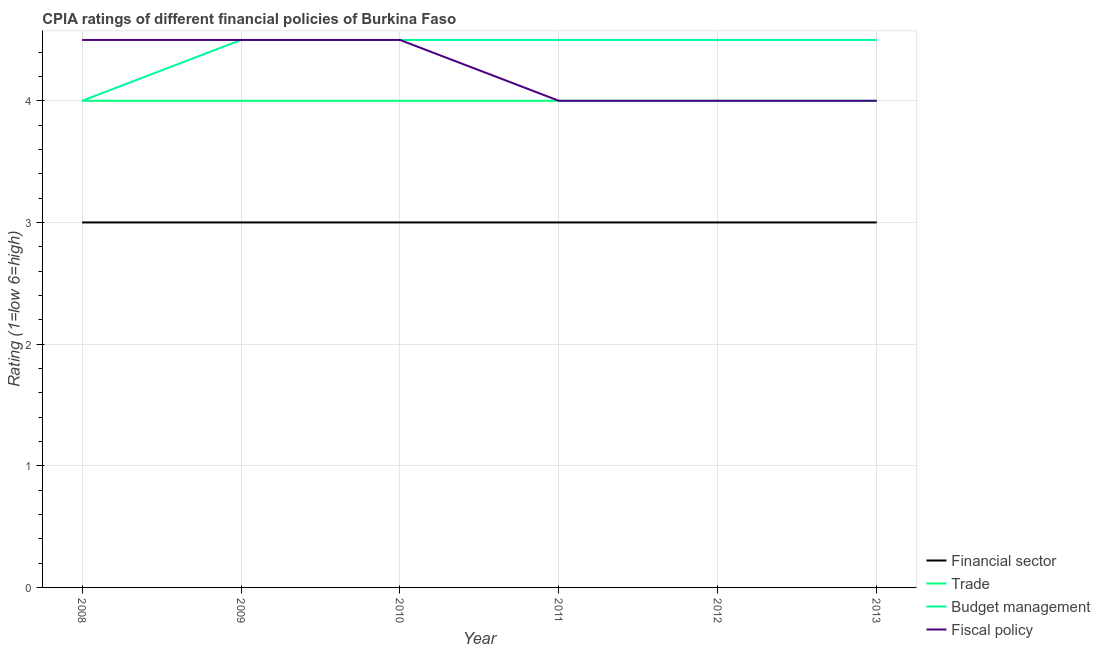How many different coloured lines are there?
Provide a short and direct response. 4. Is the number of lines equal to the number of legend labels?
Your answer should be compact. Yes. What is the cpia rating of budget management in 2009?
Your answer should be very brief. 4.5. Across all years, what is the maximum cpia rating of financial sector?
Your response must be concise. 3. What is the total cpia rating of trade in the graph?
Your answer should be compact. 24. What is the difference between the cpia rating of trade in 2009 and that in 2011?
Offer a very short reply. 0. What is the difference between the cpia rating of budget management in 2012 and the cpia rating of trade in 2009?
Ensure brevity in your answer.  0.5. What is the average cpia rating of budget management per year?
Offer a very short reply. 4.42. In the year 2008, what is the difference between the cpia rating of budget management and cpia rating of financial sector?
Make the answer very short. 1. What is the difference between the highest and the second highest cpia rating of budget management?
Offer a terse response. 0. In how many years, is the cpia rating of financial sector greater than the average cpia rating of financial sector taken over all years?
Keep it short and to the point. 0. Is it the case that in every year, the sum of the cpia rating of financial sector and cpia rating of trade is greater than the cpia rating of budget management?
Offer a very short reply. Yes. How many years are there in the graph?
Provide a short and direct response. 6. Are the values on the major ticks of Y-axis written in scientific E-notation?
Offer a very short reply. No. Does the graph contain any zero values?
Ensure brevity in your answer.  No. Does the graph contain grids?
Provide a short and direct response. Yes. What is the title of the graph?
Provide a succinct answer. CPIA ratings of different financial policies of Burkina Faso. Does "UNHCR" appear as one of the legend labels in the graph?
Offer a terse response. No. What is the label or title of the X-axis?
Your response must be concise. Year. What is the label or title of the Y-axis?
Make the answer very short. Rating (1=low 6=high). What is the Rating (1=low 6=high) of Trade in 2008?
Your answer should be compact. 4. What is the Rating (1=low 6=high) of Financial sector in 2009?
Offer a very short reply. 3. What is the Rating (1=low 6=high) in Trade in 2009?
Offer a terse response. 4. What is the Rating (1=low 6=high) of Financial sector in 2010?
Offer a very short reply. 3. What is the Rating (1=low 6=high) of Trade in 2012?
Your response must be concise. 4. What is the Rating (1=low 6=high) of Financial sector in 2013?
Provide a succinct answer. 3. What is the Rating (1=low 6=high) in Trade in 2013?
Your answer should be compact. 4. What is the Rating (1=low 6=high) in Budget management in 2013?
Give a very brief answer. 4.5. What is the Rating (1=low 6=high) of Fiscal policy in 2013?
Your answer should be very brief. 4. Across all years, what is the maximum Rating (1=low 6=high) in Financial sector?
Ensure brevity in your answer.  3. Across all years, what is the maximum Rating (1=low 6=high) in Budget management?
Give a very brief answer. 4.5. Across all years, what is the minimum Rating (1=low 6=high) of Trade?
Keep it short and to the point. 4. Across all years, what is the minimum Rating (1=low 6=high) of Budget management?
Provide a short and direct response. 4. What is the total Rating (1=low 6=high) of Budget management in the graph?
Your response must be concise. 26.5. What is the difference between the Rating (1=low 6=high) in Financial sector in 2008 and that in 2009?
Keep it short and to the point. 0. What is the difference between the Rating (1=low 6=high) of Trade in 2008 and that in 2009?
Provide a short and direct response. 0. What is the difference between the Rating (1=low 6=high) of Financial sector in 2008 and that in 2010?
Give a very brief answer. 0. What is the difference between the Rating (1=low 6=high) of Budget management in 2008 and that in 2010?
Your answer should be very brief. -0.5. What is the difference between the Rating (1=low 6=high) in Financial sector in 2008 and that in 2011?
Offer a very short reply. 0. What is the difference between the Rating (1=low 6=high) of Fiscal policy in 2008 and that in 2011?
Provide a short and direct response. 0.5. What is the difference between the Rating (1=low 6=high) in Financial sector in 2008 and that in 2012?
Make the answer very short. 0. What is the difference between the Rating (1=low 6=high) in Trade in 2008 and that in 2012?
Provide a succinct answer. 0. What is the difference between the Rating (1=low 6=high) in Fiscal policy in 2008 and that in 2012?
Provide a short and direct response. 0.5. What is the difference between the Rating (1=low 6=high) in Financial sector in 2008 and that in 2013?
Make the answer very short. 0. What is the difference between the Rating (1=low 6=high) of Trade in 2008 and that in 2013?
Make the answer very short. 0. What is the difference between the Rating (1=low 6=high) of Budget management in 2008 and that in 2013?
Offer a very short reply. -0.5. What is the difference between the Rating (1=low 6=high) in Fiscal policy in 2008 and that in 2013?
Offer a very short reply. 0.5. What is the difference between the Rating (1=low 6=high) of Financial sector in 2009 and that in 2010?
Offer a very short reply. 0. What is the difference between the Rating (1=low 6=high) in Financial sector in 2009 and that in 2011?
Offer a very short reply. 0. What is the difference between the Rating (1=low 6=high) in Trade in 2009 and that in 2011?
Give a very brief answer. 0. What is the difference between the Rating (1=low 6=high) in Budget management in 2009 and that in 2011?
Your answer should be compact. 0. What is the difference between the Rating (1=low 6=high) in Trade in 2009 and that in 2013?
Your answer should be compact. 0. What is the difference between the Rating (1=low 6=high) in Fiscal policy in 2009 and that in 2013?
Give a very brief answer. 0.5. What is the difference between the Rating (1=low 6=high) of Budget management in 2010 and that in 2011?
Your answer should be very brief. 0. What is the difference between the Rating (1=low 6=high) in Fiscal policy in 2010 and that in 2011?
Your response must be concise. 0.5. What is the difference between the Rating (1=low 6=high) of Trade in 2010 and that in 2013?
Give a very brief answer. 0. What is the difference between the Rating (1=low 6=high) of Fiscal policy in 2010 and that in 2013?
Offer a very short reply. 0.5. What is the difference between the Rating (1=low 6=high) in Budget management in 2011 and that in 2012?
Keep it short and to the point. 0. What is the difference between the Rating (1=low 6=high) of Trade in 2011 and that in 2013?
Your answer should be compact. 0. What is the difference between the Rating (1=low 6=high) of Budget management in 2011 and that in 2013?
Offer a very short reply. 0. What is the difference between the Rating (1=low 6=high) in Financial sector in 2012 and that in 2013?
Provide a succinct answer. 0. What is the difference between the Rating (1=low 6=high) in Trade in 2012 and that in 2013?
Your response must be concise. 0. What is the difference between the Rating (1=low 6=high) of Fiscal policy in 2012 and that in 2013?
Offer a terse response. 0. What is the difference between the Rating (1=low 6=high) of Financial sector in 2008 and the Rating (1=low 6=high) of Trade in 2009?
Your answer should be compact. -1. What is the difference between the Rating (1=low 6=high) of Financial sector in 2008 and the Rating (1=low 6=high) of Budget management in 2009?
Your answer should be very brief. -1.5. What is the difference between the Rating (1=low 6=high) of Financial sector in 2008 and the Rating (1=low 6=high) of Fiscal policy in 2009?
Make the answer very short. -1.5. What is the difference between the Rating (1=low 6=high) in Budget management in 2008 and the Rating (1=low 6=high) in Fiscal policy in 2009?
Your response must be concise. -0.5. What is the difference between the Rating (1=low 6=high) in Financial sector in 2008 and the Rating (1=low 6=high) in Trade in 2010?
Your response must be concise. -1. What is the difference between the Rating (1=low 6=high) in Budget management in 2008 and the Rating (1=low 6=high) in Fiscal policy in 2010?
Your response must be concise. -0.5. What is the difference between the Rating (1=low 6=high) in Financial sector in 2008 and the Rating (1=low 6=high) in Trade in 2011?
Your response must be concise. -1. What is the difference between the Rating (1=low 6=high) of Financial sector in 2008 and the Rating (1=low 6=high) of Fiscal policy in 2011?
Keep it short and to the point. -1. What is the difference between the Rating (1=low 6=high) of Trade in 2008 and the Rating (1=low 6=high) of Budget management in 2011?
Your answer should be compact. -0.5. What is the difference between the Rating (1=low 6=high) of Trade in 2008 and the Rating (1=low 6=high) of Fiscal policy in 2011?
Your answer should be compact. 0. What is the difference between the Rating (1=low 6=high) of Financial sector in 2008 and the Rating (1=low 6=high) of Trade in 2012?
Your answer should be compact. -1. What is the difference between the Rating (1=low 6=high) of Financial sector in 2008 and the Rating (1=low 6=high) of Budget management in 2012?
Keep it short and to the point. -1.5. What is the difference between the Rating (1=low 6=high) in Trade in 2008 and the Rating (1=low 6=high) in Budget management in 2012?
Offer a terse response. -0.5. What is the difference between the Rating (1=low 6=high) in Budget management in 2008 and the Rating (1=low 6=high) in Fiscal policy in 2012?
Offer a very short reply. 0. What is the difference between the Rating (1=low 6=high) of Financial sector in 2008 and the Rating (1=low 6=high) of Trade in 2013?
Provide a short and direct response. -1. What is the difference between the Rating (1=low 6=high) in Financial sector in 2008 and the Rating (1=low 6=high) in Budget management in 2013?
Your response must be concise. -1.5. What is the difference between the Rating (1=low 6=high) in Financial sector in 2008 and the Rating (1=low 6=high) in Fiscal policy in 2013?
Provide a succinct answer. -1. What is the difference between the Rating (1=low 6=high) of Budget management in 2008 and the Rating (1=low 6=high) of Fiscal policy in 2013?
Provide a succinct answer. 0. What is the difference between the Rating (1=low 6=high) in Financial sector in 2009 and the Rating (1=low 6=high) in Fiscal policy in 2010?
Make the answer very short. -1.5. What is the difference between the Rating (1=low 6=high) of Trade in 2009 and the Rating (1=low 6=high) of Budget management in 2010?
Your answer should be compact. -0.5. What is the difference between the Rating (1=low 6=high) of Financial sector in 2009 and the Rating (1=low 6=high) of Fiscal policy in 2011?
Give a very brief answer. -1. What is the difference between the Rating (1=low 6=high) of Trade in 2009 and the Rating (1=low 6=high) of Budget management in 2011?
Give a very brief answer. -0.5. What is the difference between the Rating (1=low 6=high) in Trade in 2009 and the Rating (1=low 6=high) in Fiscal policy in 2011?
Offer a very short reply. 0. What is the difference between the Rating (1=low 6=high) in Budget management in 2009 and the Rating (1=low 6=high) in Fiscal policy in 2011?
Your answer should be compact. 0.5. What is the difference between the Rating (1=low 6=high) of Financial sector in 2009 and the Rating (1=low 6=high) of Trade in 2012?
Provide a succinct answer. -1. What is the difference between the Rating (1=low 6=high) of Budget management in 2009 and the Rating (1=low 6=high) of Fiscal policy in 2012?
Offer a terse response. 0.5. What is the difference between the Rating (1=low 6=high) of Financial sector in 2009 and the Rating (1=low 6=high) of Trade in 2013?
Keep it short and to the point. -1. What is the difference between the Rating (1=low 6=high) in Financial sector in 2009 and the Rating (1=low 6=high) in Budget management in 2013?
Your response must be concise. -1.5. What is the difference between the Rating (1=low 6=high) of Financial sector in 2009 and the Rating (1=low 6=high) of Fiscal policy in 2013?
Your answer should be very brief. -1. What is the difference between the Rating (1=low 6=high) in Trade in 2009 and the Rating (1=low 6=high) in Fiscal policy in 2013?
Your answer should be compact. 0. What is the difference between the Rating (1=low 6=high) in Budget management in 2009 and the Rating (1=low 6=high) in Fiscal policy in 2013?
Your response must be concise. 0.5. What is the difference between the Rating (1=low 6=high) in Financial sector in 2010 and the Rating (1=low 6=high) in Trade in 2011?
Offer a terse response. -1. What is the difference between the Rating (1=low 6=high) of Financial sector in 2010 and the Rating (1=low 6=high) of Fiscal policy in 2011?
Ensure brevity in your answer.  -1. What is the difference between the Rating (1=low 6=high) of Trade in 2010 and the Rating (1=low 6=high) of Budget management in 2011?
Ensure brevity in your answer.  -0.5. What is the difference between the Rating (1=low 6=high) in Trade in 2010 and the Rating (1=low 6=high) in Budget management in 2012?
Your answer should be very brief. -0.5. What is the difference between the Rating (1=low 6=high) of Budget management in 2010 and the Rating (1=low 6=high) of Fiscal policy in 2012?
Keep it short and to the point. 0.5. What is the difference between the Rating (1=low 6=high) in Financial sector in 2010 and the Rating (1=low 6=high) in Trade in 2013?
Your answer should be compact. -1. What is the difference between the Rating (1=low 6=high) in Budget management in 2010 and the Rating (1=low 6=high) in Fiscal policy in 2013?
Make the answer very short. 0.5. What is the difference between the Rating (1=low 6=high) in Financial sector in 2011 and the Rating (1=low 6=high) in Trade in 2012?
Your answer should be very brief. -1. What is the difference between the Rating (1=low 6=high) in Financial sector in 2011 and the Rating (1=low 6=high) in Budget management in 2012?
Offer a terse response. -1.5. What is the difference between the Rating (1=low 6=high) in Budget management in 2011 and the Rating (1=low 6=high) in Fiscal policy in 2012?
Make the answer very short. 0.5. What is the difference between the Rating (1=low 6=high) in Financial sector in 2011 and the Rating (1=low 6=high) in Trade in 2013?
Keep it short and to the point. -1. What is the difference between the Rating (1=low 6=high) in Financial sector in 2011 and the Rating (1=low 6=high) in Budget management in 2013?
Provide a succinct answer. -1.5. What is the difference between the Rating (1=low 6=high) in Financial sector in 2011 and the Rating (1=low 6=high) in Fiscal policy in 2013?
Keep it short and to the point. -1. What is the difference between the Rating (1=low 6=high) in Trade in 2011 and the Rating (1=low 6=high) in Budget management in 2013?
Your answer should be very brief. -0.5. What is the difference between the Rating (1=low 6=high) of Budget management in 2011 and the Rating (1=low 6=high) of Fiscal policy in 2013?
Give a very brief answer. 0.5. What is the difference between the Rating (1=low 6=high) in Financial sector in 2012 and the Rating (1=low 6=high) in Trade in 2013?
Keep it short and to the point. -1. What is the difference between the Rating (1=low 6=high) of Financial sector in 2012 and the Rating (1=low 6=high) of Budget management in 2013?
Provide a short and direct response. -1.5. What is the difference between the Rating (1=low 6=high) in Financial sector in 2012 and the Rating (1=low 6=high) in Fiscal policy in 2013?
Provide a short and direct response. -1. What is the difference between the Rating (1=low 6=high) of Trade in 2012 and the Rating (1=low 6=high) of Fiscal policy in 2013?
Provide a short and direct response. 0. What is the difference between the Rating (1=low 6=high) in Budget management in 2012 and the Rating (1=low 6=high) in Fiscal policy in 2013?
Keep it short and to the point. 0.5. What is the average Rating (1=low 6=high) of Budget management per year?
Ensure brevity in your answer.  4.42. What is the average Rating (1=low 6=high) in Fiscal policy per year?
Offer a terse response. 4.25. In the year 2008, what is the difference between the Rating (1=low 6=high) in Financial sector and Rating (1=low 6=high) in Trade?
Your answer should be compact. -1. In the year 2009, what is the difference between the Rating (1=low 6=high) in Financial sector and Rating (1=low 6=high) in Budget management?
Your answer should be very brief. -1.5. In the year 2010, what is the difference between the Rating (1=low 6=high) in Financial sector and Rating (1=low 6=high) in Trade?
Your answer should be very brief. -1. In the year 2010, what is the difference between the Rating (1=low 6=high) of Trade and Rating (1=low 6=high) of Budget management?
Offer a very short reply. -0.5. In the year 2011, what is the difference between the Rating (1=low 6=high) in Trade and Rating (1=low 6=high) in Fiscal policy?
Offer a very short reply. 0. In the year 2012, what is the difference between the Rating (1=low 6=high) in Financial sector and Rating (1=low 6=high) in Budget management?
Your answer should be very brief. -1.5. In the year 2012, what is the difference between the Rating (1=low 6=high) in Financial sector and Rating (1=low 6=high) in Fiscal policy?
Ensure brevity in your answer.  -1. In the year 2012, what is the difference between the Rating (1=low 6=high) in Trade and Rating (1=low 6=high) in Budget management?
Make the answer very short. -0.5. In the year 2013, what is the difference between the Rating (1=low 6=high) of Financial sector and Rating (1=low 6=high) of Trade?
Give a very brief answer. -1. In the year 2013, what is the difference between the Rating (1=low 6=high) of Financial sector and Rating (1=low 6=high) of Budget management?
Offer a terse response. -1.5. In the year 2013, what is the difference between the Rating (1=low 6=high) in Financial sector and Rating (1=low 6=high) in Fiscal policy?
Your answer should be very brief. -1. In the year 2013, what is the difference between the Rating (1=low 6=high) in Trade and Rating (1=low 6=high) in Budget management?
Offer a very short reply. -0.5. In the year 2013, what is the difference between the Rating (1=low 6=high) in Budget management and Rating (1=low 6=high) in Fiscal policy?
Ensure brevity in your answer.  0.5. What is the ratio of the Rating (1=low 6=high) of Financial sector in 2008 to that in 2010?
Your response must be concise. 1. What is the ratio of the Rating (1=low 6=high) of Trade in 2008 to that in 2010?
Ensure brevity in your answer.  1. What is the ratio of the Rating (1=low 6=high) in Financial sector in 2008 to that in 2011?
Your answer should be compact. 1. What is the ratio of the Rating (1=low 6=high) in Trade in 2008 to that in 2011?
Provide a succinct answer. 1. What is the ratio of the Rating (1=low 6=high) in Budget management in 2008 to that in 2011?
Offer a very short reply. 0.89. What is the ratio of the Rating (1=low 6=high) of Trade in 2008 to that in 2012?
Provide a succinct answer. 1. What is the ratio of the Rating (1=low 6=high) in Financial sector in 2008 to that in 2013?
Offer a very short reply. 1. What is the ratio of the Rating (1=low 6=high) in Trade in 2008 to that in 2013?
Provide a succinct answer. 1. What is the ratio of the Rating (1=low 6=high) in Fiscal policy in 2008 to that in 2013?
Ensure brevity in your answer.  1.12. What is the ratio of the Rating (1=low 6=high) of Financial sector in 2009 to that in 2010?
Your answer should be compact. 1. What is the ratio of the Rating (1=low 6=high) in Budget management in 2009 to that in 2010?
Keep it short and to the point. 1. What is the ratio of the Rating (1=low 6=high) of Financial sector in 2009 to that in 2011?
Offer a terse response. 1. What is the ratio of the Rating (1=low 6=high) of Trade in 2009 to that in 2011?
Your response must be concise. 1. What is the ratio of the Rating (1=low 6=high) in Fiscal policy in 2009 to that in 2012?
Keep it short and to the point. 1.12. What is the ratio of the Rating (1=low 6=high) of Fiscal policy in 2009 to that in 2013?
Ensure brevity in your answer.  1.12. What is the ratio of the Rating (1=low 6=high) of Financial sector in 2010 to that in 2011?
Your answer should be compact. 1. What is the ratio of the Rating (1=low 6=high) in Budget management in 2010 to that in 2011?
Offer a very short reply. 1. What is the ratio of the Rating (1=low 6=high) of Fiscal policy in 2010 to that in 2011?
Your answer should be compact. 1.12. What is the ratio of the Rating (1=low 6=high) in Financial sector in 2010 to that in 2012?
Ensure brevity in your answer.  1. What is the ratio of the Rating (1=low 6=high) in Fiscal policy in 2010 to that in 2012?
Your answer should be very brief. 1.12. What is the ratio of the Rating (1=low 6=high) of Trade in 2010 to that in 2013?
Keep it short and to the point. 1. What is the ratio of the Rating (1=low 6=high) in Budget management in 2010 to that in 2013?
Ensure brevity in your answer.  1. What is the ratio of the Rating (1=low 6=high) in Financial sector in 2011 to that in 2012?
Give a very brief answer. 1. What is the ratio of the Rating (1=low 6=high) in Trade in 2011 to that in 2012?
Provide a short and direct response. 1. What is the ratio of the Rating (1=low 6=high) in Financial sector in 2011 to that in 2013?
Offer a terse response. 1. What is the ratio of the Rating (1=low 6=high) in Financial sector in 2012 to that in 2013?
Your answer should be compact. 1. What is the ratio of the Rating (1=low 6=high) in Trade in 2012 to that in 2013?
Offer a terse response. 1. What is the ratio of the Rating (1=low 6=high) of Fiscal policy in 2012 to that in 2013?
Give a very brief answer. 1. What is the difference between the highest and the second highest Rating (1=low 6=high) in Financial sector?
Make the answer very short. 0. What is the difference between the highest and the second highest Rating (1=low 6=high) of Trade?
Provide a short and direct response. 0. 